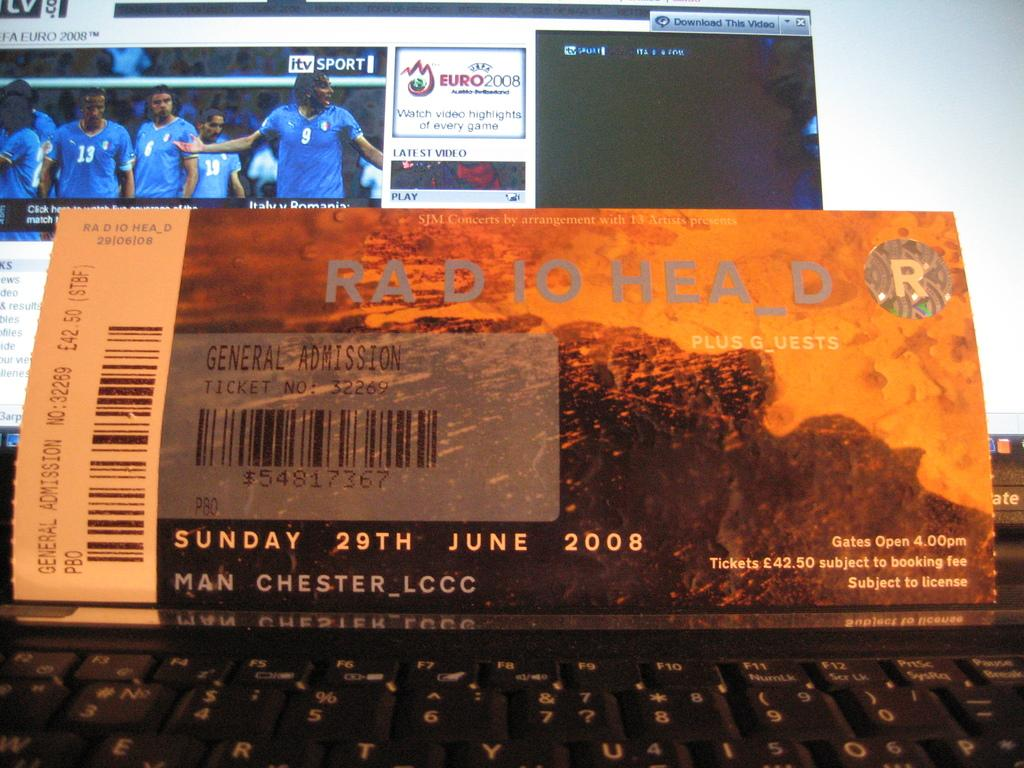<image>
Present a compact description of the photo's key features. the name radio head is on the ticket 